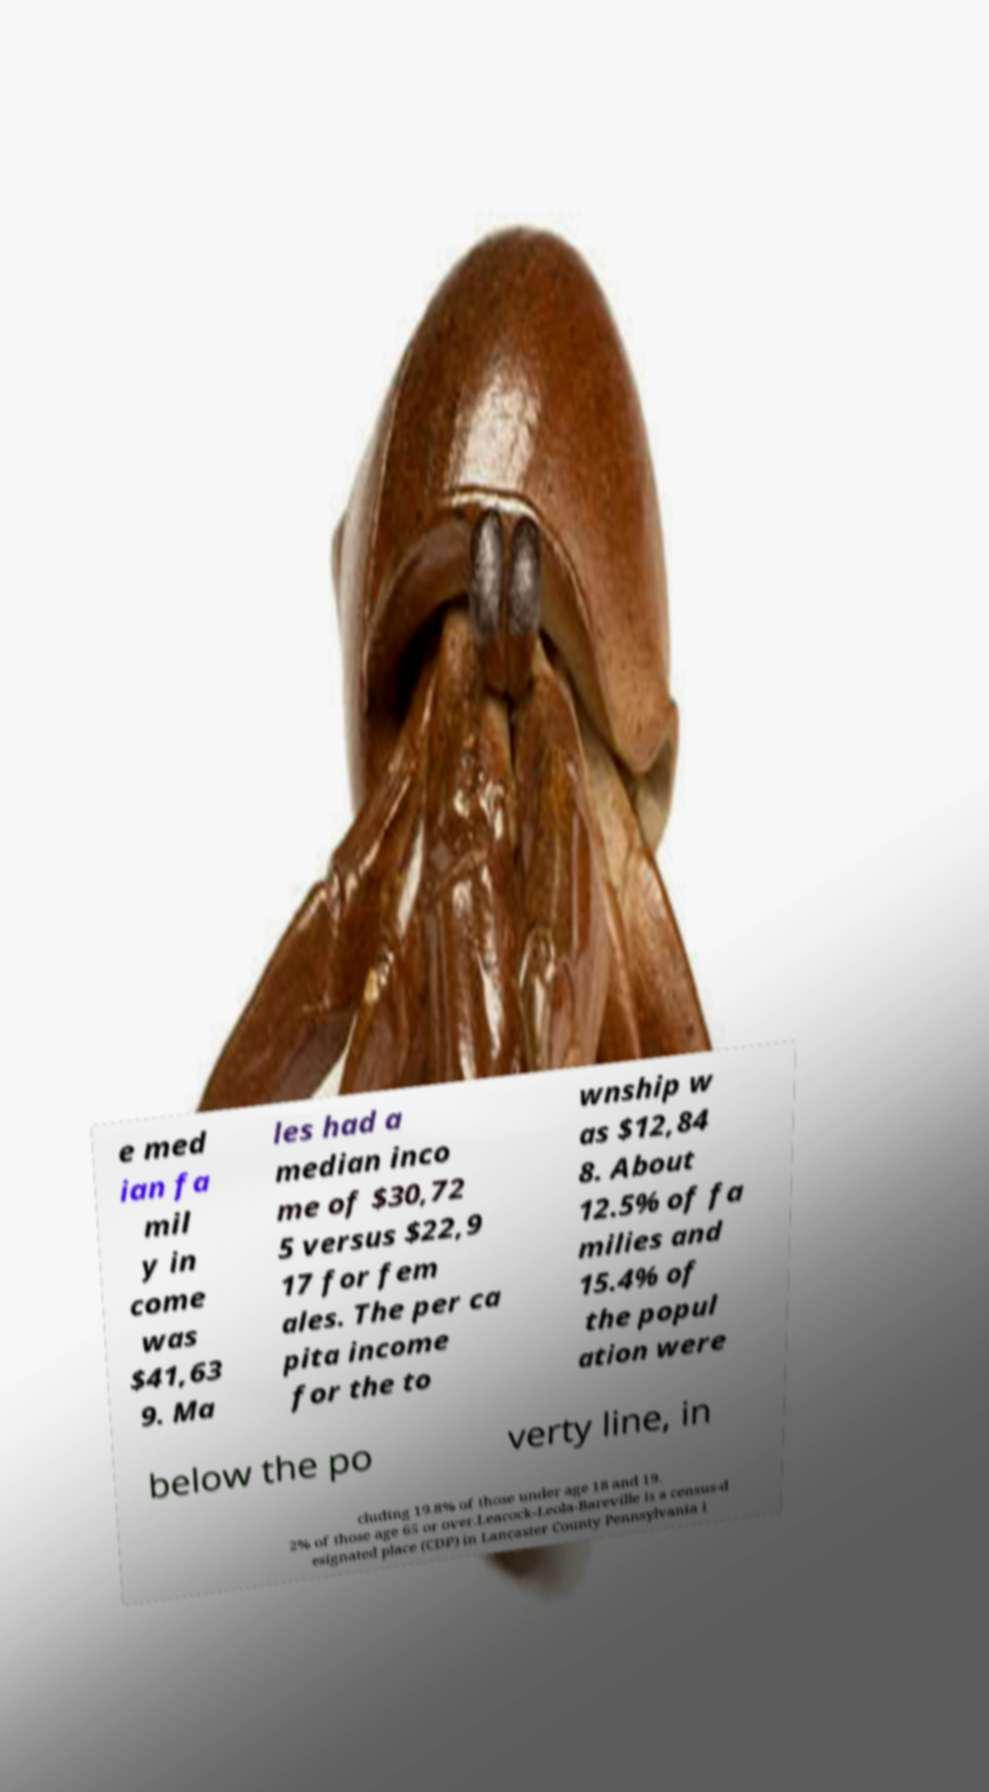Could you extract and type out the text from this image? e med ian fa mil y in come was $41,63 9. Ma les had a median inco me of $30,72 5 versus $22,9 17 for fem ales. The per ca pita income for the to wnship w as $12,84 8. About 12.5% of fa milies and 15.4% of the popul ation were below the po verty line, in cluding 19.8% of those under age 18 and 19. 2% of those age 65 or over.Leacock-Leola-Bareville is a census-d esignated place (CDP) in Lancaster County Pennsylvania i 